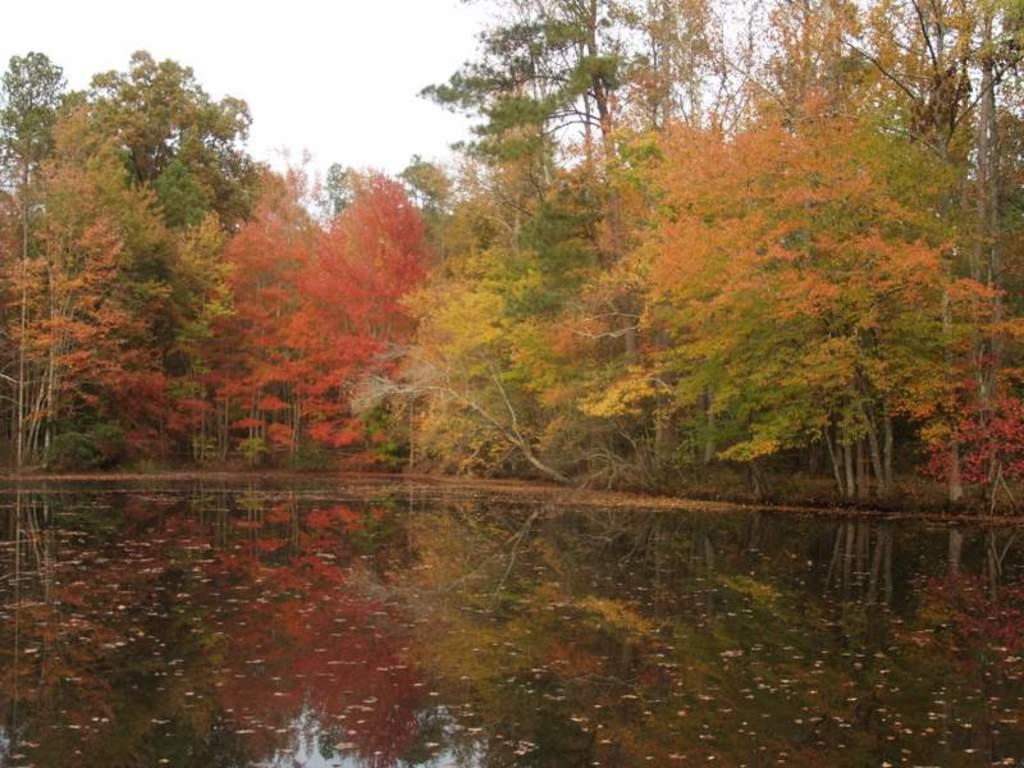What type of natural feature is at the bottom of the image? There is a river at the bottom of the image. What can be seen in the background of the image? There are many trees in the background of the image. What is visible at the top of the image? The sky is visible at the top of the image. How many rays can be seen jumping over the river in the image? There are no rays present in the image, and rays cannot jump. What type of trail is visible in the image? There is no trail visible in the image. 